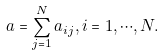Convert formula to latex. <formula><loc_0><loc_0><loc_500><loc_500>a = \sum _ { j = 1 } ^ { N } a _ { i j } , i = 1 , \cdots , N .</formula> 